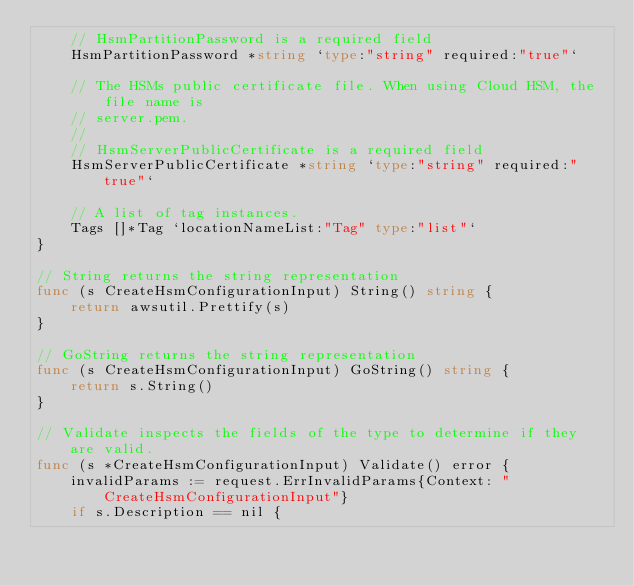<code> <loc_0><loc_0><loc_500><loc_500><_Go_>	// HsmPartitionPassword is a required field
	HsmPartitionPassword *string `type:"string" required:"true"`

	// The HSMs public certificate file. When using Cloud HSM, the file name is
	// server.pem.
	//
	// HsmServerPublicCertificate is a required field
	HsmServerPublicCertificate *string `type:"string" required:"true"`

	// A list of tag instances.
	Tags []*Tag `locationNameList:"Tag" type:"list"`
}

// String returns the string representation
func (s CreateHsmConfigurationInput) String() string {
	return awsutil.Prettify(s)
}

// GoString returns the string representation
func (s CreateHsmConfigurationInput) GoString() string {
	return s.String()
}

// Validate inspects the fields of the type to determine if they are valid.
func (s *CreateHsmConfigurationInput) Validate() error {
	invalidParams := request.ErrInvalidParams{Context: "CreateHsmConfigurationInput"}
	if s.Description == nil {</code> 